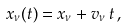Convert formula to latex. <formula><loc_0><loc_0><loc_500><loc_500>x _ { \nu } ( t ) = x _ { \nu } + v _ { \nu } \, t \, ,</formula> 